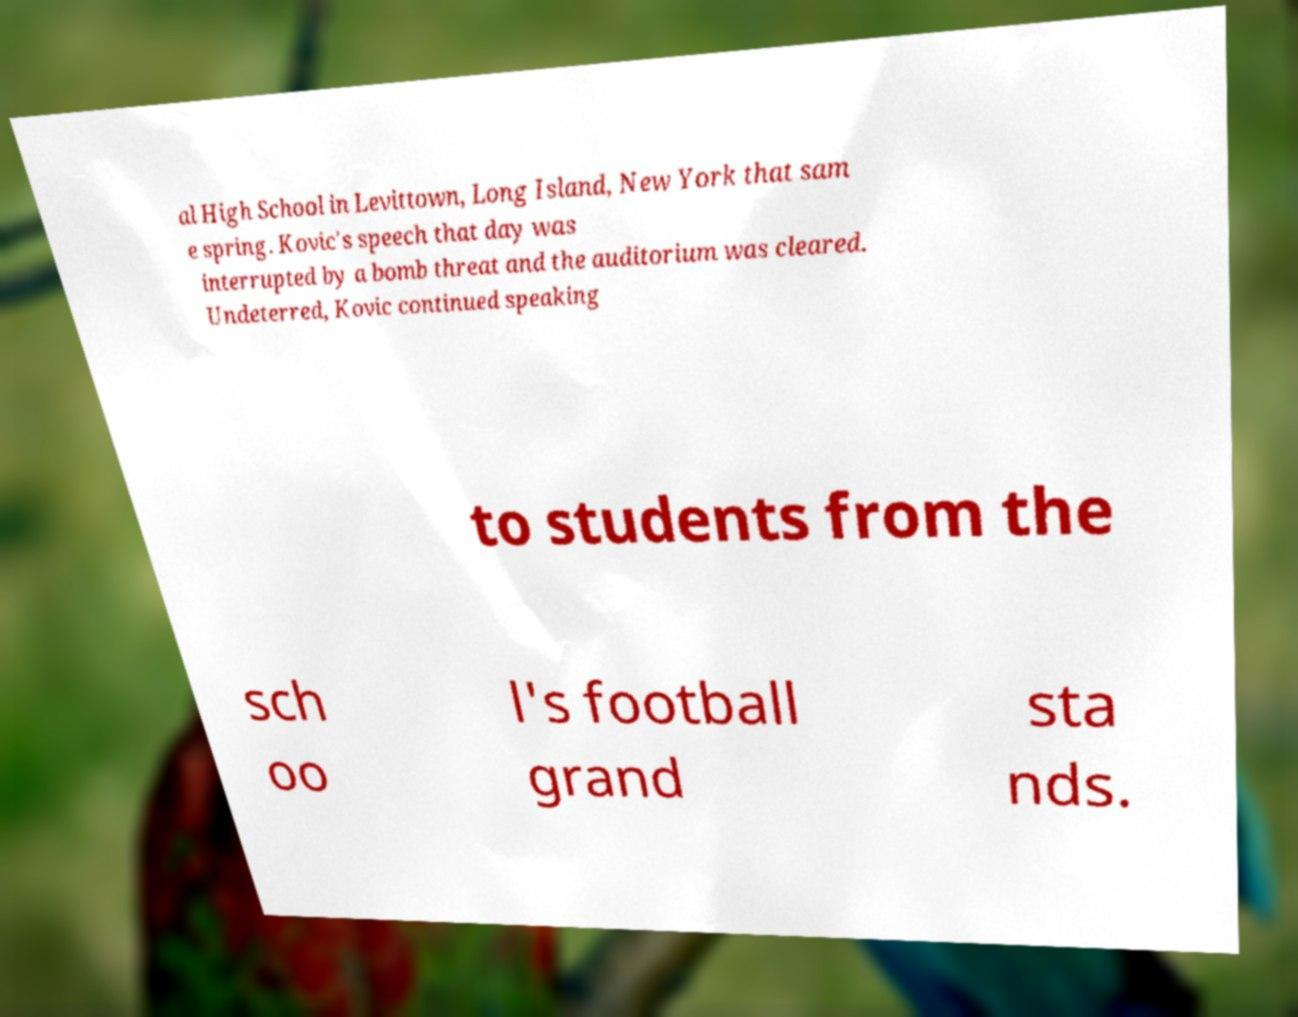Can you accurately transcribe the text from the provided image for me? al High School in Levittown, Long Island, New York that sam e spring. Kovic's speech that day was interrupted by a bomb threat and the auditorium was cleared. Undeterred, Kovic continued speaking to students from the sch oo l's football grand sta nds. 